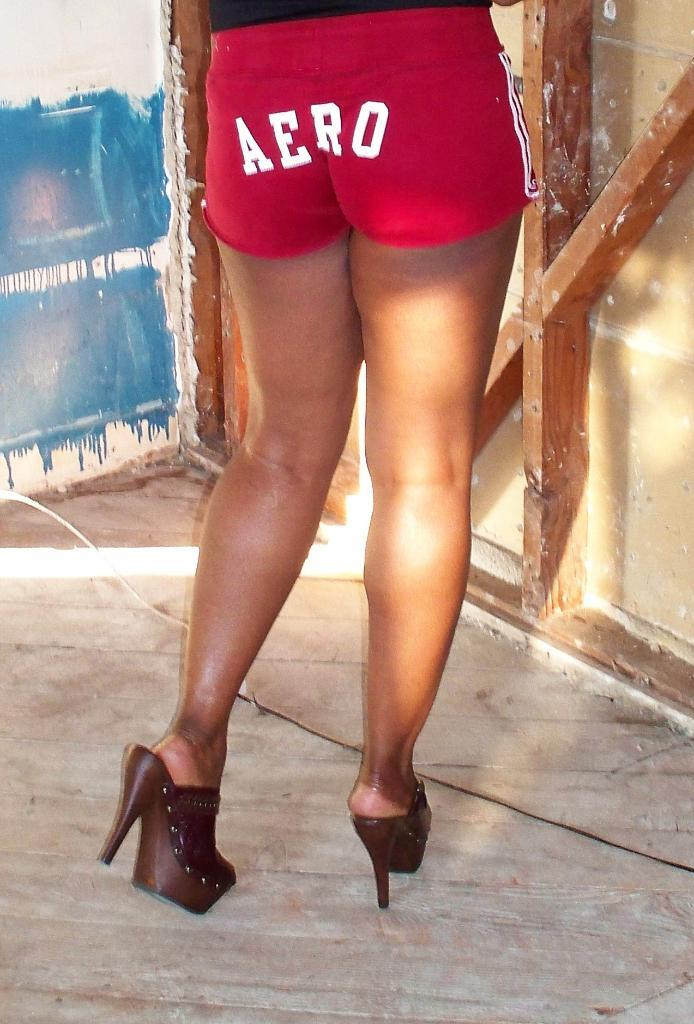<image>
Relay a brief, clear account of the picture shown. A woman from the waist down is wearing red shorts with the word AERO across her butt with high heeled sandals. 